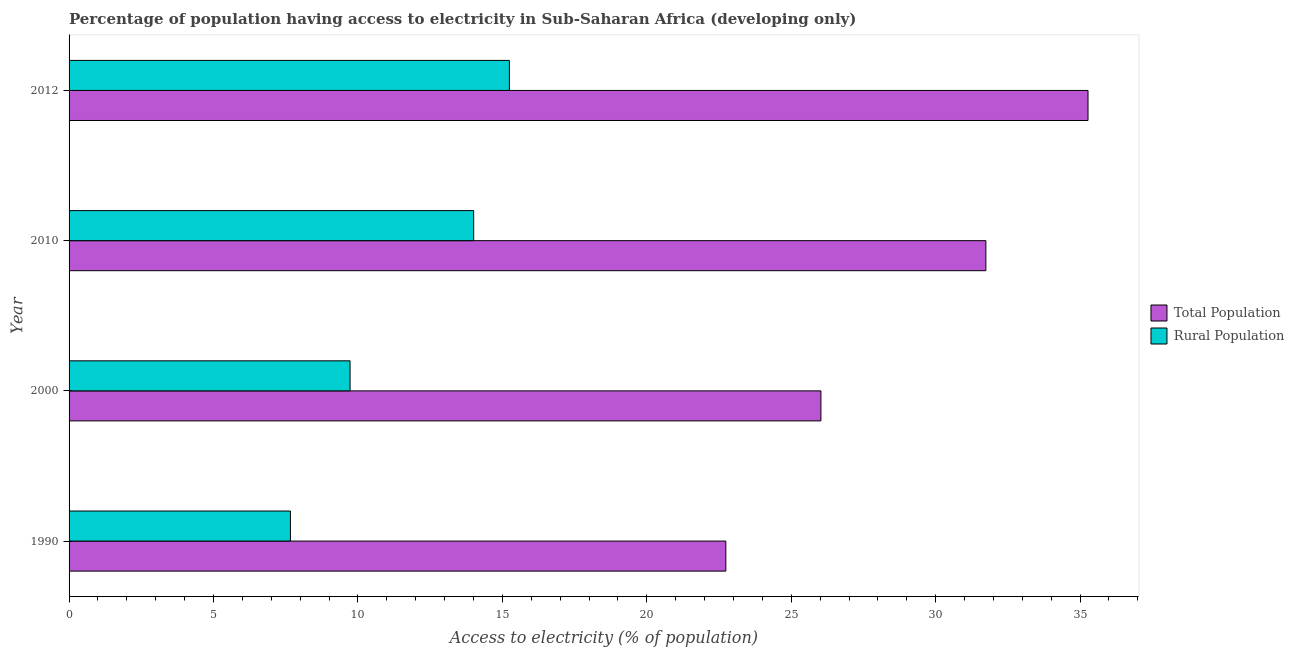How many different coloured bars are there?
Ensure brevity in your answer.  2. How many bars are there on the 3rd tick from the bottom?
Give a very brief answer. 2. What is the percentage of population having access to electricity in 2012?
Your answer should be compact. 35.27. Across all years, what is the maximum percentage of rural population having access to electricity?
Keep it short and to the point. 15.24. Across all years, what is the minimum percentage of rural population having access to electricity?
Your answer should be compact. 7.66. In which year was the percentage of rural population having access to electricity minimum?
Offer a very short reply. 1990. What is the total percentage of rural population having access to electricity in the graph?
Ensure brevity in your answer.  46.64. What is the difference between the percentage of population having access to electricity in 1990 and that in 2000?
Ensure brevity in your answer.  -3.29. What is the difference between the percentage of rural population having access to electricity in 2012 and the percentage of population having access to electricity in 1990?
Your response must be concise. -7.49. What is the average percentage of population having access to electricity per year?
Your answer should be compact. 28.94. In the year 2012, what is the difference between the percentage of rural population having access to electricity and percentage of population having access to electricity?
Provide a short and direct response. -20.03. What is the ratio of the percentage of population having access to electricity in 1990 to that in 2010?
Your response must be concise. 0.72. What is the difference between the highest and the second highest percentage of rural population having access to electricity?
Provide a succinct answer. 1.24. What is the difference between the highest and the lowest percentage of population having access to electricity?
Your response must be concise. 12.54. Is the sum of the percentage of rural population having access to electricity in 2000 and 2012 greater than the maximum percentage of population having access to electricity across all years?
Ensure brevity in your answer.  No. What does the 2nd bar from the top in 1990 represents?
Offer a very short reply. Total Population. What does the 1st bar from the bottom in 2012 represents?
Keep it short and to the point. Total Population. How many bars are there?
Keep it short and to the point. 8. Are all the bars in the graph horizontal?
Give a very brief answer. Yes. How many years are there in the graph?
Give a very brief answer. 4. Does the graph contain any zero values?
Make the answer very short. No. How many legend labels are there?
Provide a succinct answer. 2. How are the legend labels stacked?
Offer a very short reply. Vertical. What is the title of the graph?
Make the answer very short. Percentage of population having access to electricity in Sub-Saharan Africa (developing only). What is the label or title of the X-axis?
Offer a terse response. Access to electricity (% of population). What is the Access to electricity (% of population) in Total Population in 1990?
Provide a short and direct response. 22.74. What is the Access to electricity (% of population) in Rural Population in 1990?
Offer a terse response. 7.66. What is the Access to electricity (% of population) in Total Population in 2000?
Your answer should be very brief. 26.03. What is the Access to electricity (% of population) in Rural Population in 2000?
Provide a short and direct response. 9.73. What is the Access to electricity (% of population) of Total Population in 2010?
Provide a succinct answer. 31.74. What is the Access to electricity (% of population) of Rural Population in 2010?
Your answer should be very brief. 14.01. What is the Access to electricity (% of population) in Total Population in 2012?
Give a very brief answer. 35.27. What is the Access to electricity (% of population) in Rural Population in 2012?
Provide a short and direct response. 15.24. Across all years, what is the maximum Access to electricity (% of population) in Total Population?
Offer a terse response. 35.27. Across all years, what is the maximum Access to electricity (% of population) of Rural Population?
Offer a very short reply. 15.24. Across all years, what is the minimum Access to electricity (% of population) in Total Population?
Your answer should be very brief. 22.74. Across all years, what is the minimum Access to electricity (% of population) of Rural Population?
Keep it short and to the point. 7.66. What is the total Access to electricity (% of population) in Total Population in the graph?
Your response must be concise. 115.78. What is the total Access to electricity (% of population) in Rural Population in the graph?
Make the answer very short. 46.64. What is the difference between the Access to electricity (% of population) of Total Population in 1990 and that in 2000?
Your answer should be compact. -3.29. What is the difference between the Access to electricity (% of population) in Rural Population in 1990 and that in 2000?
Give a very brief answer. -2.06. What is the difference between the Access to electricity (% of population) in Total Population in 1990 and that in 2010?
Give a very brief answer. -9. What is the difference between the Access to electricity (% of population) of Rural Population in 1990 and that in 2010?
Ensure brevity in your answer.  -6.34. What is the difference between the Access to electricity (% of population) in Total Population in 1990 and that in 2012?
Keep it short and to the point. -12.54. What is the difference between the Access to electricity (% of population) in Rural Population in 1990 and that in 2012?
Your answer should be very brief. -7.58. What is the difference between the Access to electricity (% of population) in Total Population in 2000 and that in 2010?
Your answer should be compact. -5.71. What is the difference between the Access to electricity (% of population) in Rural Population in 2000 and that in 2010?
Provide a succinct answer. -4.28. What is the difference between the Access to electricity (% of population) of Total Population in 2000 and that in 2012?
Your response must be concise. -9.25. What is the difference between the Access to electricity (% of population) of Rural Population in 2000 and that in 2012?
Your response must be concise. -5.52. What is the difference between the Access to electricity (% of population) in Total Population in 2010 and that in 2012?
Give a very brief answer. -3.54. What is the difference between the Access to electricity (% of population) in Rural Population in 2010 and that in 2012?
Offer a very short reply. -1.24. What is the difference between the Access to electricity (% of population) of Total Population in 1990 and the Access to electricity (% of population) of Rural Population in 2000?
Your answer should be very brief. 13.01. What is the difference between the Access to electricity (% of population) of Total Population in 1990 and the Access to electricity (% of population) of Rural Population in 2010?
Your answer should be very brief. 8.73. What is the difference between the Access to electricity (% of population) of Total Population in 1990 and the Access to electricity (% of population) of Rural Population in 2012?
Offer a very short reply. 7.49. What is the difference between the Access to electricity (% of population) of Total Population in 2000 and the Access to electricity (% of population) of Rural Population in 2010?
Make the answer very short. 12.02. What is the difference between the Access to electricity (% of population) of Total Population in 2000 and the Access to electricity (% of population) of Rural Population in 2012?
Your answer should be compact. 10.78. What is the difference between the Access to electricity (% of population) of Total Population in 2010 and the Access to electricity (% of population) of Rural Population in 2012?
Your answer should be compact. 16.5. What is the average Access to electricity (% of population) of Total Population per year?
Give a very brief answer. 28.94. What is the average Access to electricity (% of population) in Rural Population per year?
Your answer should be compact. 11.66. In the year 1990, what is the difference between the Access to electricity (% of population) in Total Population and Access to electricity (% of population) in Rural Population?
Give a very brief answer. 15.07. In the year 2000, what is the difference between the Access to electricity (% of population) in Total Population and Access to electricity (% of population) in Rural Population?
Your response must be concise. 16.3. In the year 2010, what is the difference between the Access to electricity (% of population) in Total Population and Access to electricity (% of population) in Rural Population?
Provide a succinct answer. 17.73. In the year 2012, what is the difference between the Access to electricity (% of population) in Total Population and Access to electricity (% of population) in Rural Population?
Keep it short and to the point. 20.03. What is the ratio of the Access to electricity (% of population) in Total Population in 1990 to that in 2000?
Your answer should be compact. 0.87. What is the ratio of the Access to electricity (% of population) of Rural Population in 1990 to that in 2000?
Provide a short and direct response. 0.79. What is the ratio of the Access to electricity (% of population) of Total Population in 1990 to that in 2010?
Your response must be concise. 0.72. What is the ratio of the Access to electricity (% of population) in Rural Population in 1990 to that in 2010?
Ensure brevity in your answer.  0.55. What is the ratio of the Access to electricity (% of population) of Total Population in 1990 to that in 2012?
Your response must be concise. 0.64. What is the ratio of the Access to electricity (% of population) of Rural Population in 1990 to that in 2012?
Keep it short and to the point. 0.5. What is the ratio of the Access to electricity (% of population) of Total Population in 2000 to that in 2010?
Provide a short and direct response. 0.82. What is the ratio of the Access to electricity (% of population) of Rural Population in 2000 to that in 2010?
Offer a very short reply. 0.69. What is the ratio of the Access to electricity (% of population) in Total Population in 2000 to that in 2012?
Offer a terse response. 0.74. What is the ratio of the Access to electricity (% of population) of Rural Population in 2000 to that in 2012?
Offer a very short reply. 0.64. What is the ratio of the Access to electricity (% of population) in Total Population in 2010 to that in 2012?
Provide a short and direct response. 0.9. What is the ratio of the Access to electricity (% of population) of Rural Population in 2010 to that in 2012?
Your response must be concise. 0.92. What is the difference between the highest and the second highest Access to electricity (% of population) of Total Population?
Give a very brief answer. 3.54. What is the difference between the highest and the second highest Access to electricity (% of population) of Rural Population?
Ensure brevity in your answer.  1.24. What is the difference between the highest and the lowest Access to electricity (% of population) of Total Population?
Ensure brevity in your answer.  12.54. What is the difference between the highest and the lowest Access to electricity (% of population) of Rural Population?
Give a very brief answer. 7.58. 